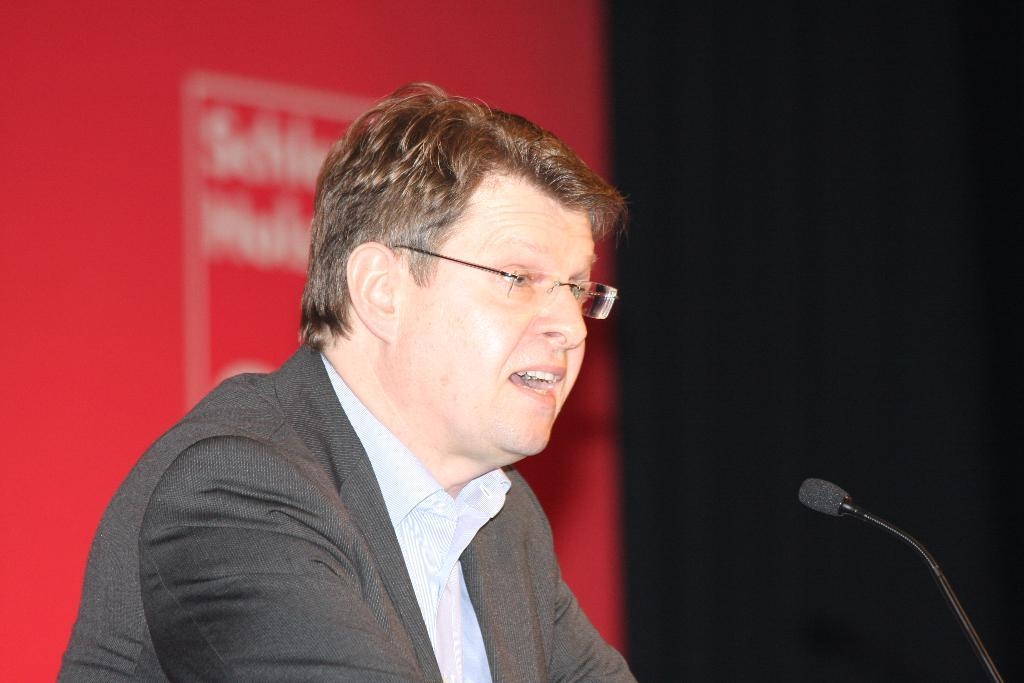What is the main subject of the image? There is a man standing in the center of the image. Can you describe any objects near the man? There is a mic on the right side of the image. What type of drink is the man holding in the image? There is no drink present in the image; the man is not holding anything. 